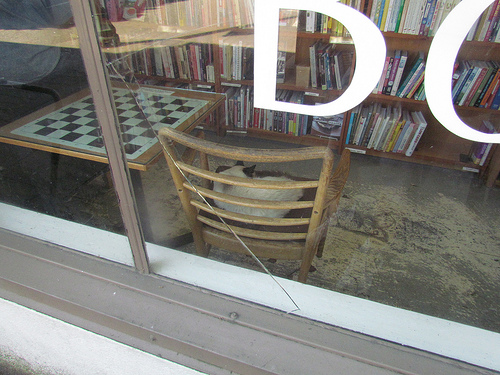<image>
Is there a window on the chair? No. The window is not positioned on the chair. They may be near each other, but the window is not supported by or resting on top of the chair. 